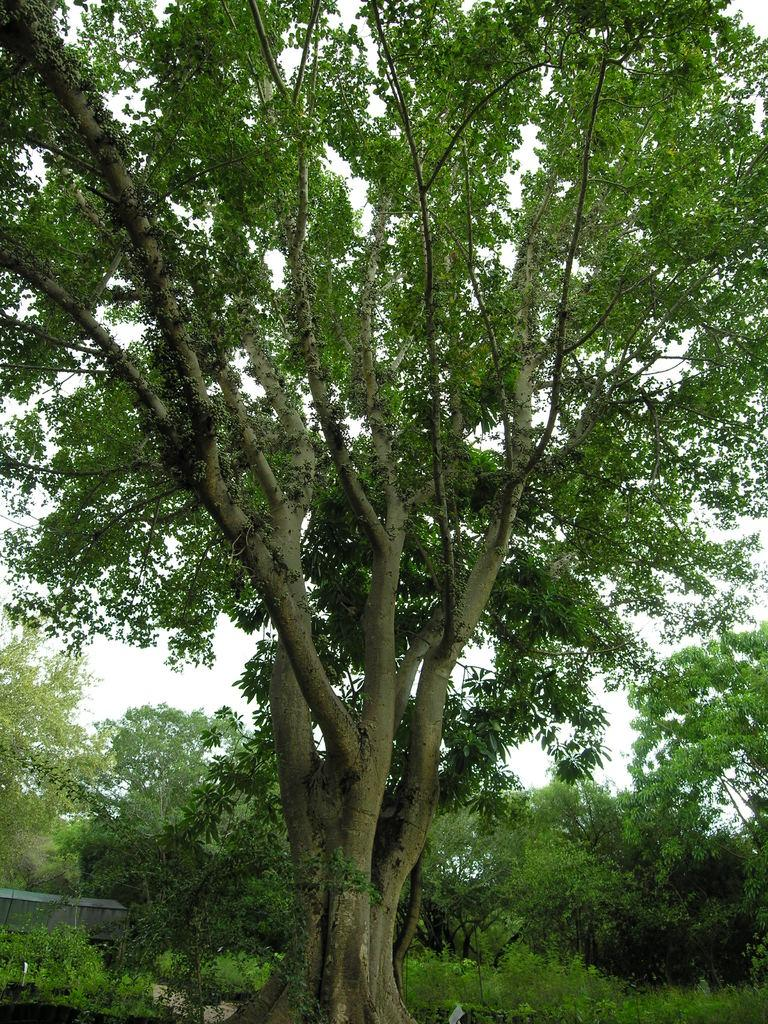What is the main feature in the image? There is a big tree in the image. What can be seen on the left side of the image? There is a box-like structure on the left side of the image. What is visible in the background of the image? There are trees and the sky visible in the background of the image. What type of brake is attached to the tree in the image? There is no brake present in the image; it features a big tree and a box-like structure. Can you see a tramp performing in the background of the image? There is no tramp performing in the image; it only shows a big tree, a box-like structure, trees in the background, and the sky. 